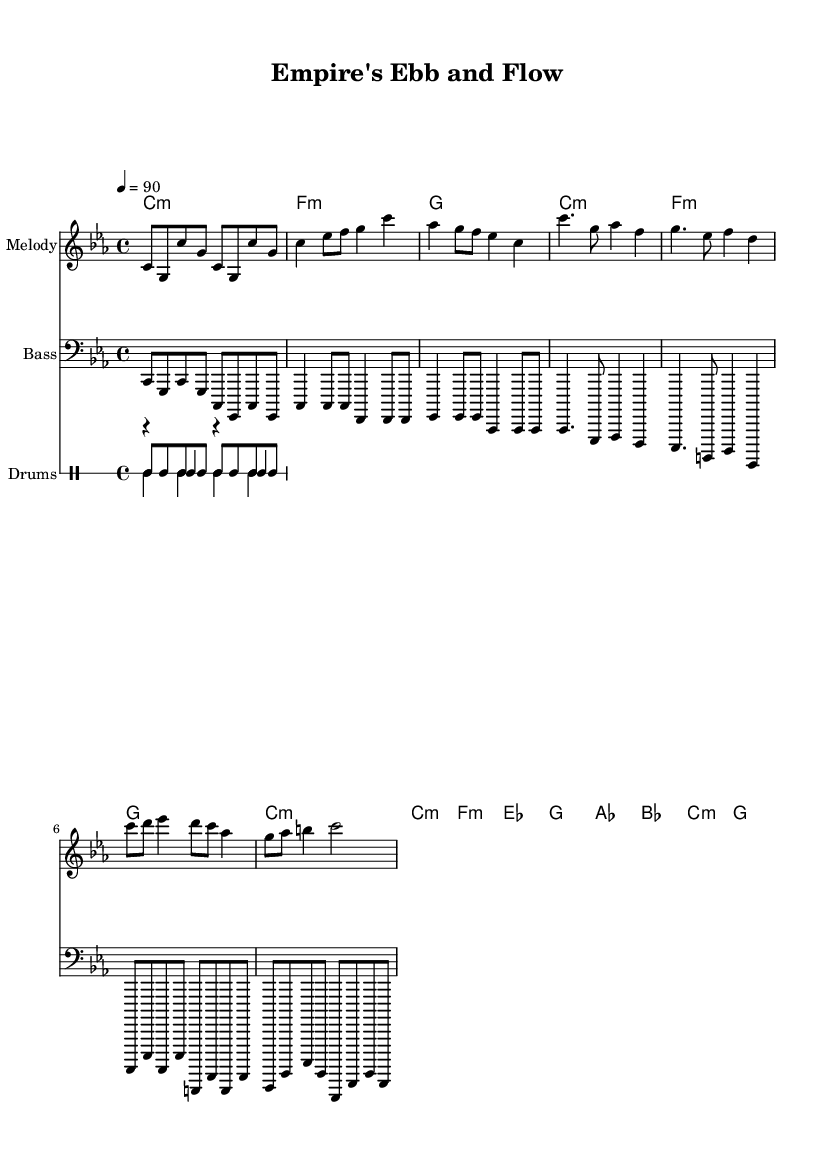What is the key signature of this music? The key signature is C minor, which has three flats: B flat, E flat, and A flat. This can be identified by the presence of the flats on the staff next to the clef.
Answer: C minor What is the time signature of the piece? The time signature is 4/4, meaning there are four beats in each measure and the quarter note gets one beat. This can be seen in the beginning of the sheet music where the time signature is indicated.
Answer: 4/4 What is the tempo marking for this hip hop piece? The tempo marking is 4 equals 90, indicating a metronome setting of 90 beats per minute. This is found at the beginning of the score, next to the tempo indication.
Answer: 90 How many measures are in the verse section? The verse section consists of 4 measures as indicated by the musical notation in that section. The measures can be counted visually by looking at the bar lines.
Answer: 4 What chord follows the A flat chord in the bridge section? The chord that follows the A flat chord in the bridge section is B flat. This is determined by looking at the chord progression written in the harmonies section corresponding to that part of the melody.
Answer: B flat What type of rhythm pattern is primarily used in the drum pattern? The primary rhythm pattern used for the drums is a steady eighth-note pattern for the hi-hat. This can be inferred from how the hi-hat pattern is notated with consistent short notes throughout the rhythm.
Answer: Eighth-note What specific musical style does this piece represent? This piece represents hip hop music, as indicated by its rhythmic structure and use of spoken word-like melodies that narrate themes relevant to colonial history. The elements of the groove and the beat align with traditional characteristics of hip hop.
Answer: Hip hop 